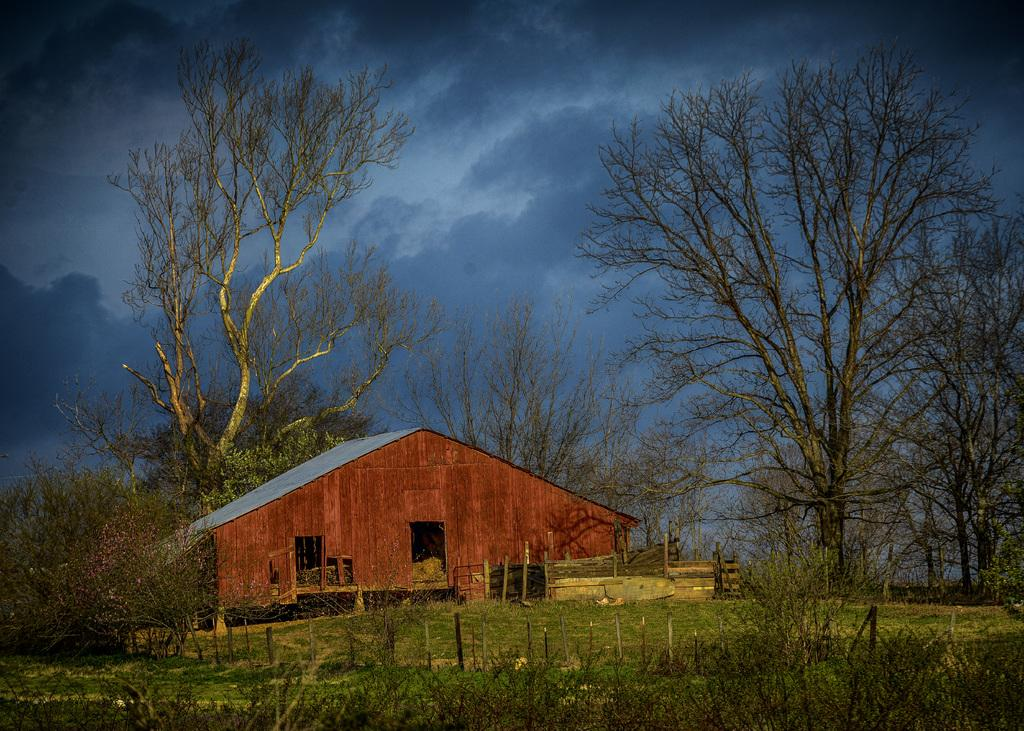What type of terrain is depicted in the image? There is a grassy land in the image. What structure can be seen at the bottom of the image? A house is present at the bottom of the image. What type of vegetation is in the middle of the image? There are trees in the middle of the image. What is visible in the background of the image? The sky is visible in the background of the image. How many basketballs can be seen in the image? There are no basketballs present in the image. What level of experience does the father have in the image? There is no father or indication of experience in the image. 